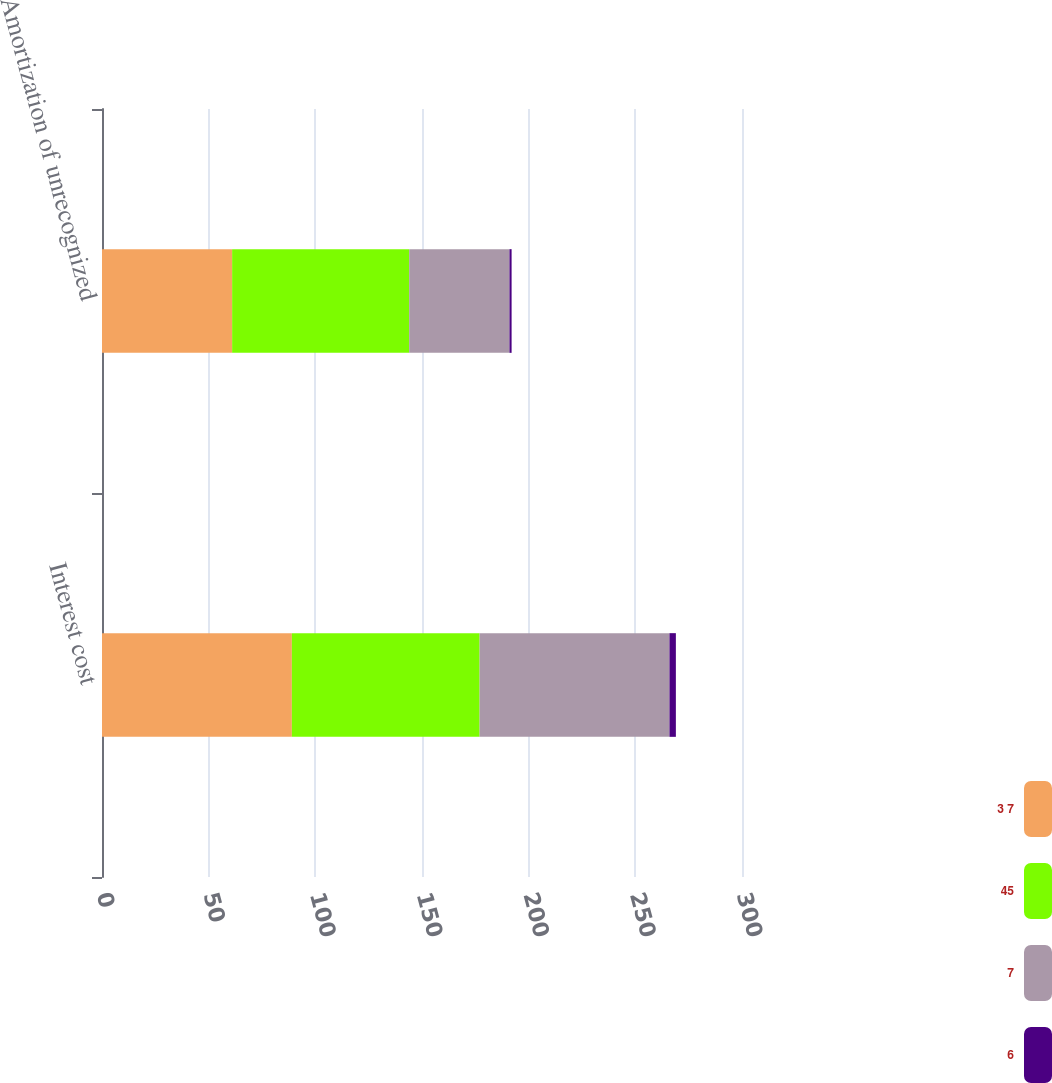<chart> <loc_0><loc_0><loc_500><loc_500><stacked_bar_chart><ecel><fcel>Interest cost<fcel>Amortization of unrecognized<nl><fcel>3 7<fcel>89<fcel>61<nl><fcel>45<fcel>88<fcel>83<nl><fcel>7<fcel>89<fcel>47<nl><fcel>6<fcel>3<fcel>1<nl></chart> 